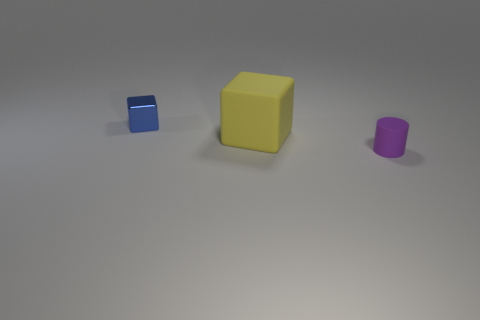Are the large yellow cube and the tiny blue block made of the same material?
Your response must be concise. No. Does the small thing to the left of the yellow thing have the same shape as the rubber thing that is on the right side of the large yellow rubber thing?
Provide a short and direct response. No. What is the tiny cube made of?
Provide a succinct answer. Metal. What number of objects are the same size as the matte cylinder?
Your response must be concise. 1. How many objects are either tiny objects that are on the left side of the tiny cylinder or tiny objects to the left of the large rubber block?
Your answer should be very brief. 1. Does the tiny thing to the right of the yellow block have the same material as the cube that is to the left of the yellow matte thing?
Make the answer very short. No. The tiny thing in front of the small thing behind the purple rubber object is what shape?
Provide a short and direct response. Cylinder. Is there anything else of the same color as the big thing?
Provide a short and direct response. No. Is there a purple matte thing on the left side of the tiny thing that is behind the small thing in front of the blue metallic block?
Offer a very short reply. No. Is the color of the rubber object behind the tiny purple cylinder the same as the block that is behind the yellow block?
Provide a succinct answer. No. 